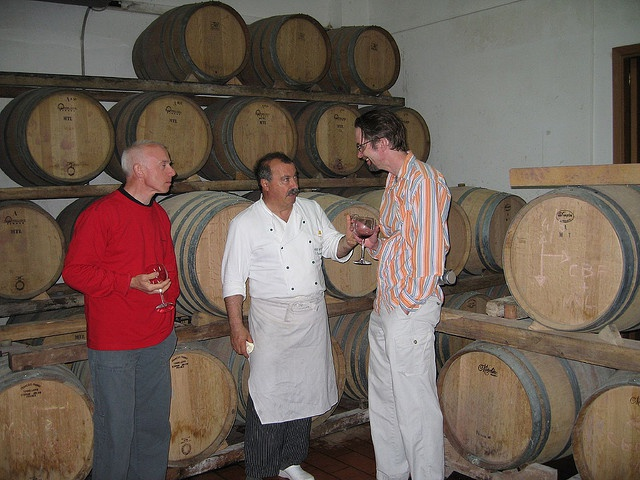Describe the objects in this image and their specific colors. I can see people in black, darkgray, lightgray, and brown tones, people in black, brown, and gray tones, people in black, darkgray, lightgray, salmon, and lightpink tones, and wine glass in black, maroon, and brown tones in this image. 